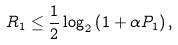<formula> <loc_0><loc_0><loc_500><loc_500>& R _ { 1 } \leq \frac { 1 } { 2 } \log _ { 2 } \left ( 1 + \alpha P _ { 1 } \right ) ,</formula> 